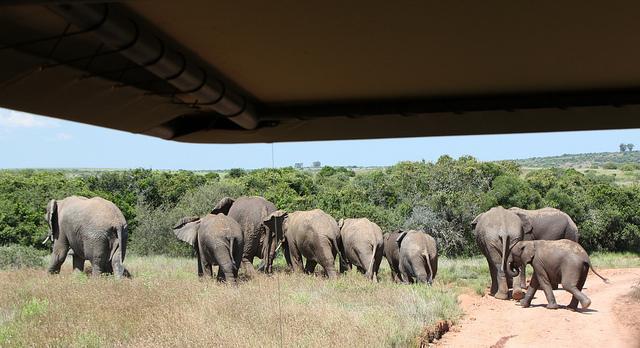How many elephants are pictured?
Give a very brief answer. 9. How many elephants can you see?
Give a very brief answer. 7. 